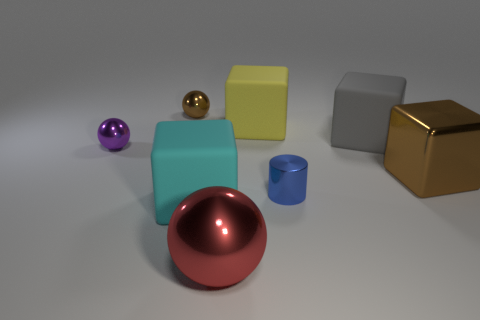Is the shape of the small purple metal object the same as the small brown object?
Your answer should be very brief. Yes. What number of other things are there of the same shape as the gray rubber thing?
Your response must be concise. 3. There is a matte block that is to the right of the big yellow rubber object; what color is it?
Offer a very short reply. Gray. Is the size of the metal block the same as the cyan matte block?
Make the answer very short. Yes. What material is the gray cube that is on the right side of the small metal sphere that is behind the large gray cube made of?
Provide a succinct answer. Rubber. What number of metallic cylinders are the same color as the large shiny sphere?
Ensure brevity in your answer.  0. Is the number of big gray objects left of the yellow thing less than the number of yellow rubber blocks?
Provide a succinct answer. Yes. What color is the tiny metal sphere that is in front of the brown shiny thing that is to the left of the big cyan thing?
Provide a succinct answer. Purple. There is a brown thing that is right of the small thing on the right side of the matte block that is in front of the small metallic cylinder; how big is it?
Keep it short and to the point. Large. Are there fewer large red metallic spheres behind the cyan rubber thing than small brown things to the left of the big gray block?
Your response must be concise. Yes. 